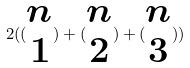<formula> <loc_0><loc_0><loc_500><loc_500>2 ( ( \begin{matrix} n \\ 1 \end{matrix} ) + ( \begin{matrix} n \\ 2 \end{matrix} ) + ( \begin{matrix} n \\ 3 \end{matrix} ) )</formula> 